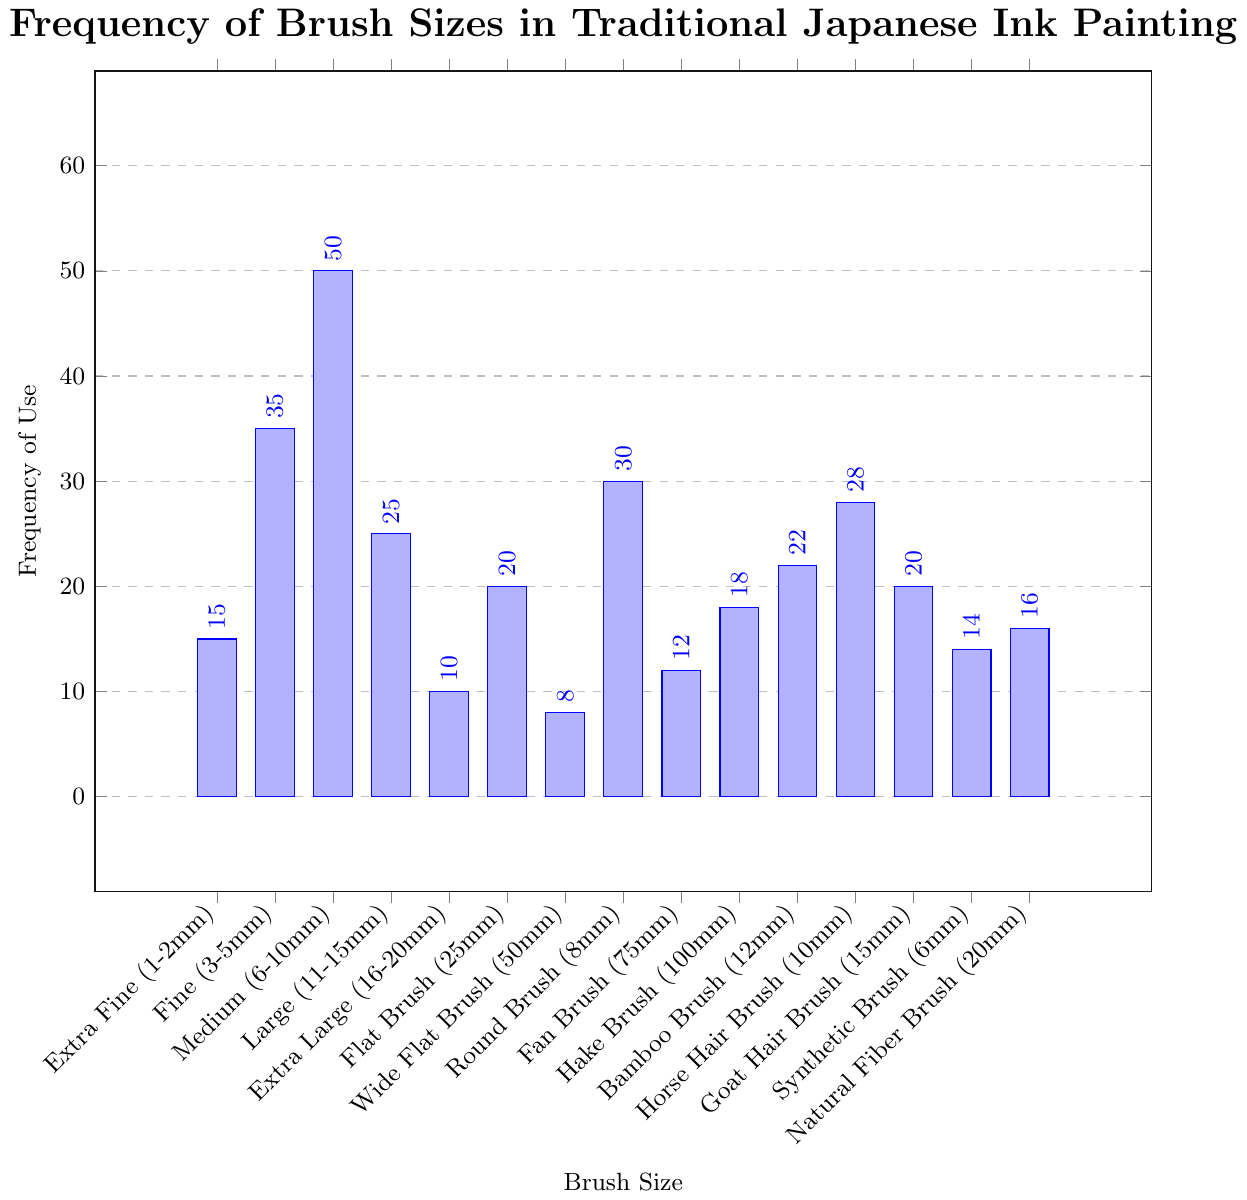What is the most frequently used brush size? The most frequently used brush size corresponds to the tallest bar in the bar chart. The tallest bar represents the “Medium (6-10mm)” brush size with a frequency of 50.
Answer: Medium (6-10mm) Which brush sizes have a usage frequency greater than 20 but less than 30? Identify the bars that lie between the frequencies of 20 and 30. The frequencies 22, 25, and 28 correspond to the brush sizes “Large (11-15mm)”, “Bamboo Brush (12mm)”, and “Horse Hair Brush (10mm)”, respectively.
Answer: Large (11-15mm), Bamboo Brush (12mm), Horse Hair Brush (10mm) What is the combined frequency of “Fine (3-5mm)” and “Round Brush (8mm)” sizes? To find the combined frequency, add the frequency of “Fine (3-5mm)” which is 35, and “Round Brush (8mm)” which is 30. Thus, 35 + 30 = 65.
Answer: 65 Which brush size is used exactly twice as often as “Extra Fine (1-2mm)” size? First, determine the frequency of “Extra Fine (1-2mm)” which is 15. Then, check for any brush size with a frequency of 15 × 2 = 30. The “Round Brush (8mm)” has a frequency of 30.
Answer: Round Brush (8mm) How many brush sizes have a higher frequency of use than the “Flat Brush (25mm)” size? The frequency of the “Flat Brush (25mm)” size is 20. Brush sizes with higher frequencies are: “Fine (3-5mm)” (35), “Medium (6-10mm)” (50), “Large (11-15mm)” (25), “Round Brush (8mm)” (30), “Horse Hair Brush (10mm)” (28), and “Bamboo Brush (12mm)” (22). Counting these gives a total of 6.
Answer: 6 Which brush sizes are tied in frequency of use at 20? Identify bars with the frequency of 20. Both the “Flat Brush (25mm)” and the “Goat Hair Brush (15mm)” have this frequency.
Answer: Flat Brush (25mm), Goat Hair Brush (15mm) How does the frequency of the “Fan Brush (75mm)” compare to the “Hake Brush (100mm)”? The “Fan Brush (75mm)” has a frequency of 12 while the “Hake Brush (100mm)” has a frequency of 18. To compare, 12 < 18, so the “Fan Brush” is used less frequently than the “Hake Brush”.
Answer: Fan Brush (75mm) is used less frequently Which brush size has the lowest frequency of use? The shortest bar indicates the lowest frequency. The “Wide Flat Brush (50mm)” has the shortest bar with a frequency of 8.
Answer: Wide Flat Brush (50mm) What is the average frequency of the “Extra Fine (1-2mm)”, “Horse Hair Brush (10mm)”, and “Bamboo Brush (12mm)” sizes? Calculate the average by adding their frequencies: 15 (Extra Fine) + 28 (Horse Hair Brush) + 22 (Bamboo Brush) = 65, then divide by 3: 65 / 3 ≈ 21.67.
Answer: 21.67 